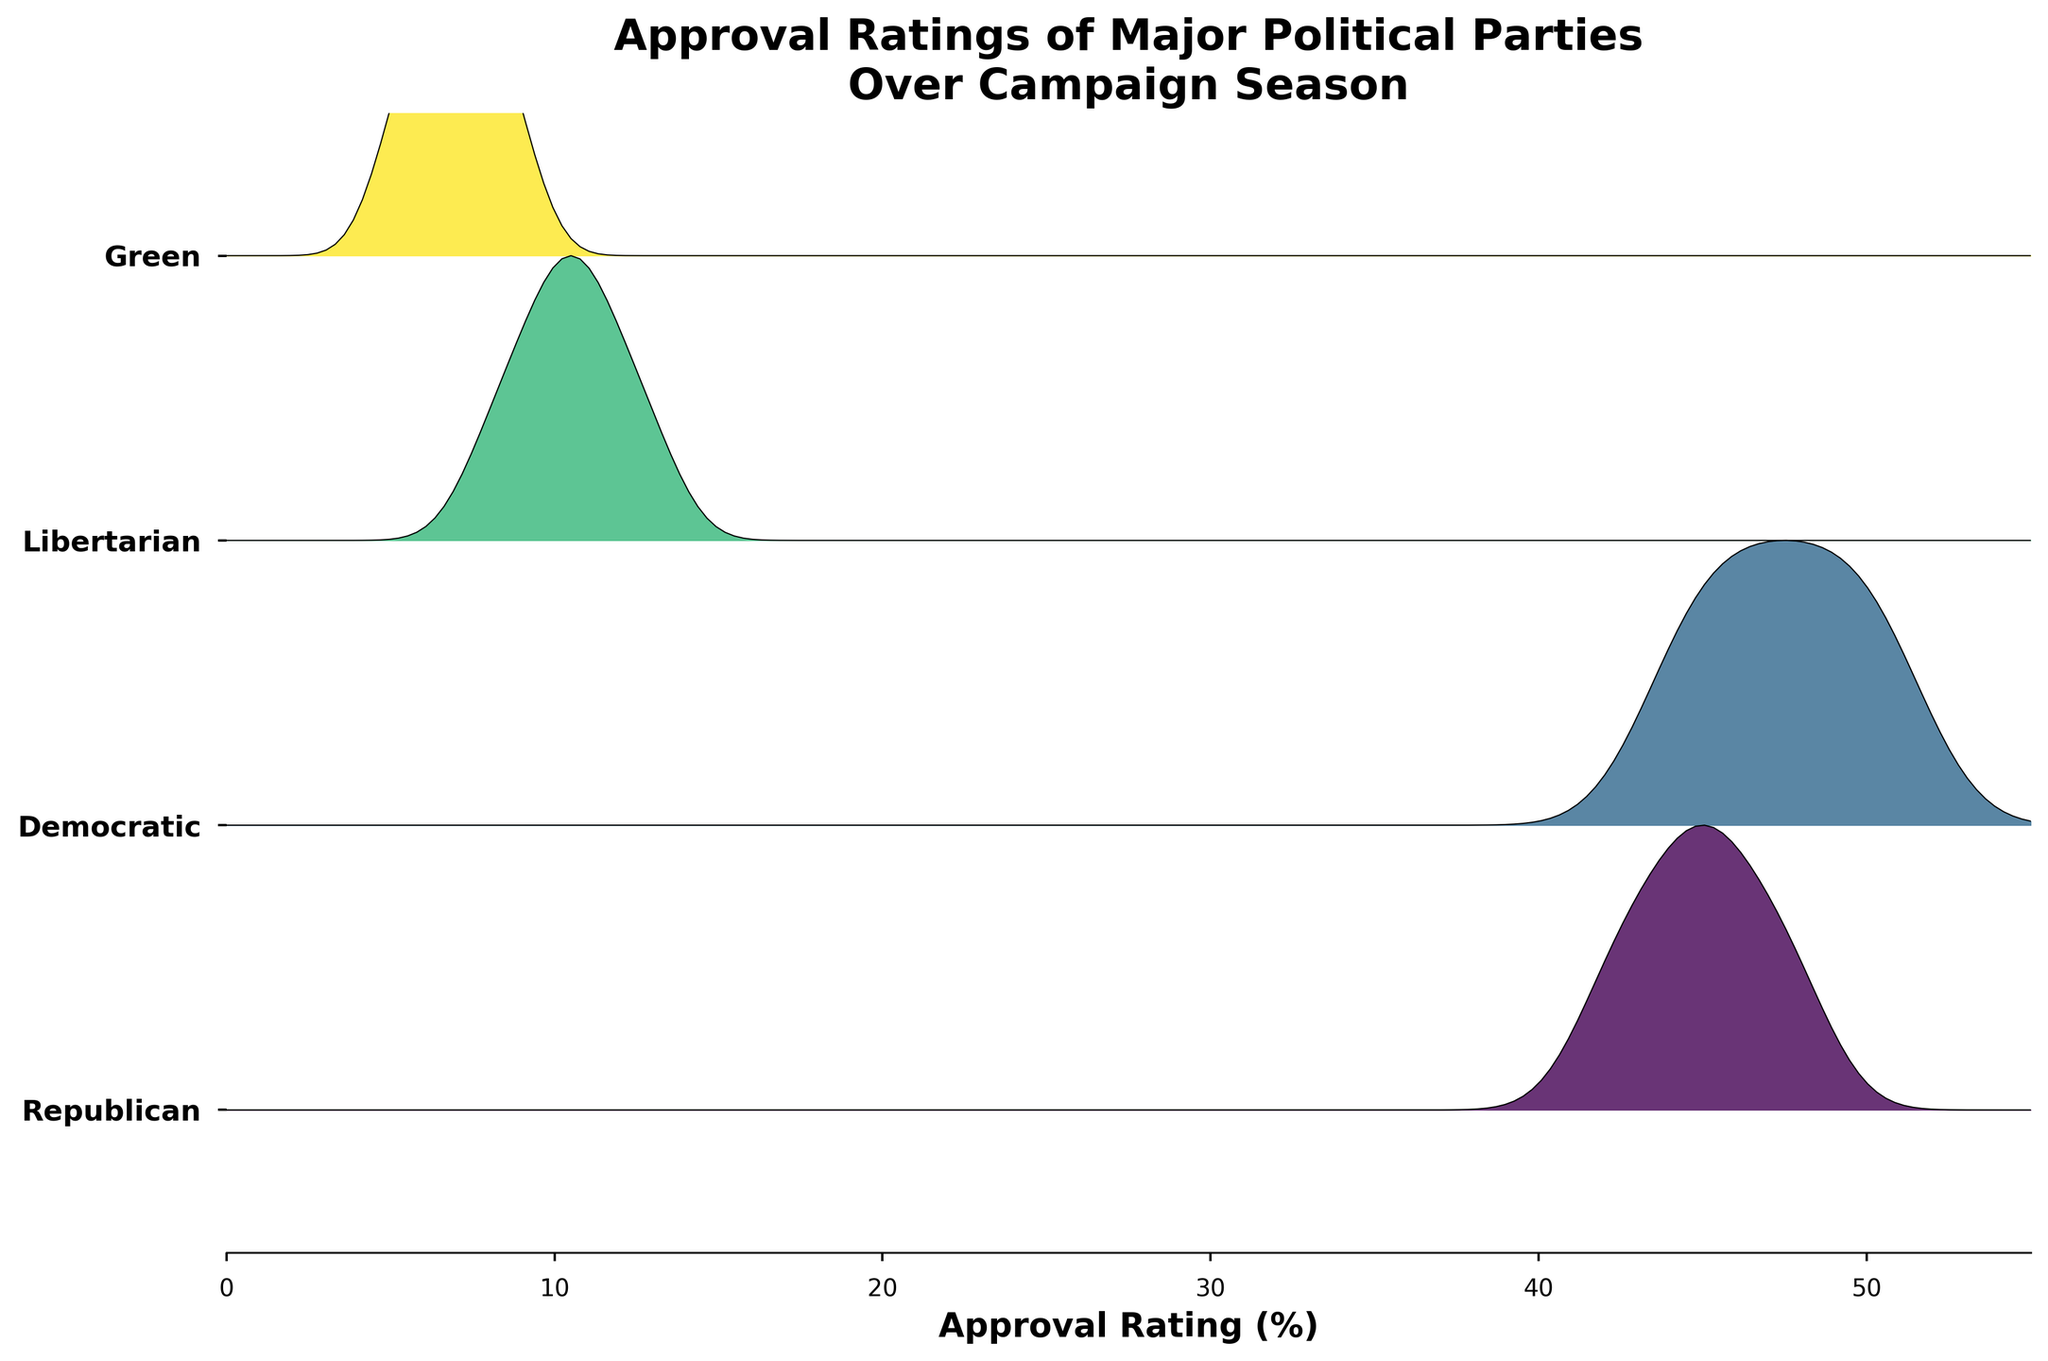Which party has the highest approval rating in week 8? The ridgeline plot shows that the Democratic party has the highest approval rating in week 8, around 51%.
Answer: Democratic How does the Republican party's approval rating change from week 1 to week 8? In the ridgeline plot, the Republican party's approval rating increases from approximately 42% in week 1 to around 48% in week 8.
Answer: It increases Which party shows the greatest fluctuation in approval ratings over the campaign season? The Democratic party shows the greatest fluctuation in the ridgeline plot, with approval ratings ranging from around 44% to 51%.
Answer: Democratic Do any parties have overlapping approval ratings at any point during the campaign season? By comparing the densities in the ridgeline plot, we can see that the Republican and Democratic parties have overlapping approval ratings around 45-47% during the early weeks of the campaign season.
Answer: Yes, Republican and Democratic What's the difference in approval rating between the Green and Libertarian parties in week 4? From the ridgeline plot, the Green party has an approval rating of about 6% in week 4, while the Libertarian party has around 11%. The difference is 11% - 6% = 5%.
Answer: 5% Which parties show a consistent increase in approval ratings throughout the campaign season? The ridgeline plot demonstrates that both the Libertarian and Democratic parties show a consistent increase in approval ratings throughout the campaign season.
Answer: Libertarian and Democratic How does the approval rating of the Green party in week 1 compare to the Libertarian party in week 1? The impact of the Green party's approval rating can be seen to be around 5% in week 1, which is lower than the Libertarian party's 8% approval rating during the same week.
Answer: Green is lower By how many percentage points does the Democratic party's highest weekly approval rating differ from the Republican party's highest weekly approval rating? The ridgeline plot shows the Democratic party's highest weekly approval rating is around 51%, and the Republican party’s highest weekly approval rating is around 48%. The difference is 51% - 48% = 3%.
Answer: 3% During which weeks do all parties have the highest collective approval ratings? We observe from the ridgeline plot that all parties collectively peak in approval ratings around week 8.
Answer: Week 8 